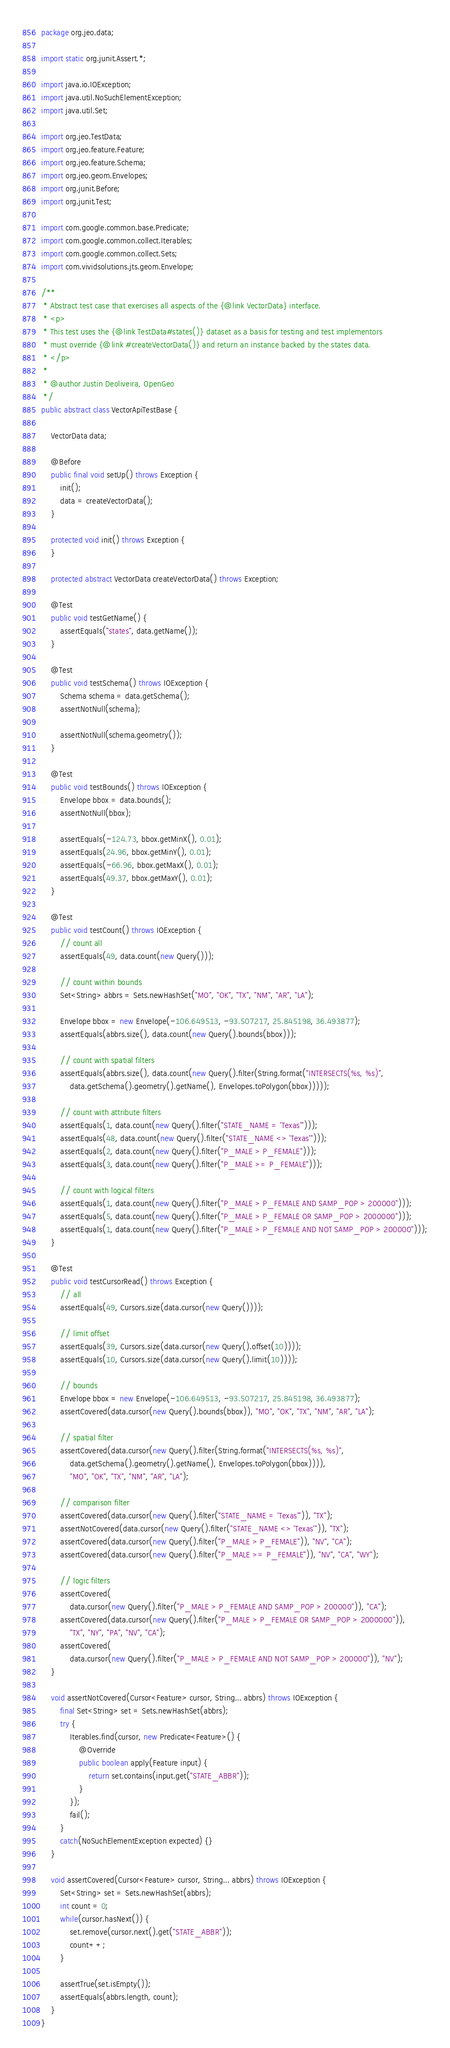Convert code to text. <code><loc_0><loc_0><loc_500><loc_500><_Java_>package org.jeo.data;

import static org.junit.Assert.*;

import java.io.IOException;
import java.util.NoSuchElementException;
import java.util.Set;

import org.jeo.TestData;
import org.jeo.feature.Feature;
import org.jeo.feature.Schema;
import org.jeo.geom.Envelopes;
import org.junit.Before;
import org.junit.Test;

import com.google.common.base.Predicate;
import com.google.common.collect.Iterables;
import com.google.common.collect.Sets;
import com.vividsolutions.jts.geom.Envelope;

/**
 * Abstract test case that exercises all aspects of the {@link VectorData} interface.
 * <p>
 * This test uses the {@link TestData#states()} dataset as a basis for testing and test implementors
 * must override {@link #createVectorData()} and return an instance backed by the states data.
 * </p>
 * 
 * @author Justin Deoliveira, OpenGeo
 */
public abstract class VectorApiTestBase {

    VectorData data;

    @Before
    public final void setUp() throws Exception {
        init();
        data = createVectorData();
    }

    protected void init() throws Exception {
    }

    protected abstract VectorData createVectorData() throws Exception;

    @Test
    public void testGetName() {
        assertEquals("states", data.getName());
    }

    @Test
    public void testSchema() throws IOException {
        Schema schema = data.getSchema();
        assertNotNull(schema);

        assertNotNull(schema.geometry());
    }

    @Test
    public void testBounds() throws IOException {
        Envelope bbox = data.bounds();
        assertNotNull(bbox);

        assertEquals(-124.73, bbox.getMinX(), 0.01);
        assertEquals(24.96, bbox.getMinY(), 0.01);
        assertEquals(-66.96, bbox.getMaxX(), 0.01);
        assertEquals(49.37, bbox.getMaxY(), 0.01);
    }

    @Test
    public void testCount() throws IOException {
        // count all
        assertEquals(49, data.count(new Query()));

        // count within bounds
        Set<String> abbrs = Sets.newHashSet("MO", "OK", "TX", "NM", "AR", "LA"); 

        Envelope bbox = new Envelope(-106.649513, -93.507217, 25.845198, 36.493877);
        assertEquals(abbrs.size(), data.count(new Query().bounds(bbox)));

        // count with spatial filters
        assertEquals(abbrs.size(), data.count(new Query().filter(String.format("INTERSECTS(%s, %s)", 
            data.getSchema().geometry().getName(), Envelopes.toPolygon(bbox)))));

        // count with attribute filters
        assertEquals(1, data.count(new Query().filter("STATE_NAME = 'Texas'")));
        assertEquals(48, data.count(new Query().filter("STATE_NAME <> 'Texas'")));
        assertEquals(2, data.count(new Query().filter("P_MALE > P_FEMALE")));
        assertEquals(3, data.count(new Query().filter("P_MALE >= P_FEMALE")));

        // count with logical filters
        assertEquals(1, data.count(new Query().filter("P_MALE > P_FEMALE AND SAMP_POP > 200000")));
        assertEquals(5, data.count(new Query().filter("P_MALE > P_FEMALE OR SAMP_POP > 2000000")));
        assertEquals(1, data.count(new Query().filter("P_MALE > P_FEMALE AND NOT SAMP_POP > 200000")));
    }

    @Test
    public void testCursorRead() throws Exception {
        // all
        assertEquals(49, Cursors.size(data.cursor(new Query())));

        // limit offset
        assertEquals(39, Cursors.size(data.cursor(new Query().offset(10))));
        assertEquals(10, Cursors.size(data.cursor(new Query().limit(10))));

        // bounds
        Envelope bbox = new Envelope(-106.649513, -93.507217, 25.845198, 36.493877);
        assertCovered(data.cursor(new Query().bounds(bbox)), "MO", "OK", "TX", "NM", "AR", "LA");

        // spatial filter
        assertCovered(data.cursor(new Query().filter(String.format("INTERSECTS(%s, %s)", 
            data.getSchema().geometry().getName(), Envelopes.toPolygon(bbox)))), 
            "MO", "OK", "TX", "NM", "AR", "LA");

        // comparison filter
        assertCovered(data.cursor(new Query().filter("STATE_NAME = 'Texas'")), "TX");
        assertNotCovered(data.cursor(new Query().filter("STATE_NAME <> 'Texas'")), "TX");
        assertCovered(data.cursor(new Query().filter("P_MALE > P_FEMALE")), "NV", "CA");
        assertCovered(data.cursor(new Query().filter("P_MALE >= P_FEMALE")), "NV", "CA", "WY");

        // logic filters
        assertCovered(
            data.cursor(new Query().filter("P_MALE > P_FEMALE AND SAMP_POP > 200000")), "CA");
        assertCovered(data.cursor(new Query().filter("P_MALE > P_FEMALE OR SAMP_POP > 2000000")), 
            "TX", "NY", "PA", "NV", "CA");
        assertCovered(
            data.cursor(new Query().filter("P_MALE > P_FEMALE AND NOT SAMP_POP > 200000")), "NV");
    }

    void assertNotCovered(Cursor<Feature> cursor, String... abbrs) throws IOException {
        final Set<String> set = Sets.newHashSet(abbrs);
        try {
            Iterables.find(cursor, new Predicate<Feature>() {
                @Override
                public boolean apply(Feature input) {
                    return set.contains(input.get("STATE_ABBR"));
                }
            });
            fail();
        }
        catch(NoSuchElementException expected) {}
    }

    void assertCovered(Cursor<Feature> cursor, String... abbrs) throws IOException {
        Set<String> set = Sets.newHashSet(abbrs);
        int count = 0;
        while(cursor.hasNext()) {
            set.remove(cursor.next().get("STATE_ABBR"));
            count++;
        }

        assertTrue(set.isEmpty());
        assertEquals(abbrs.length, count);
    }
}
</code> 